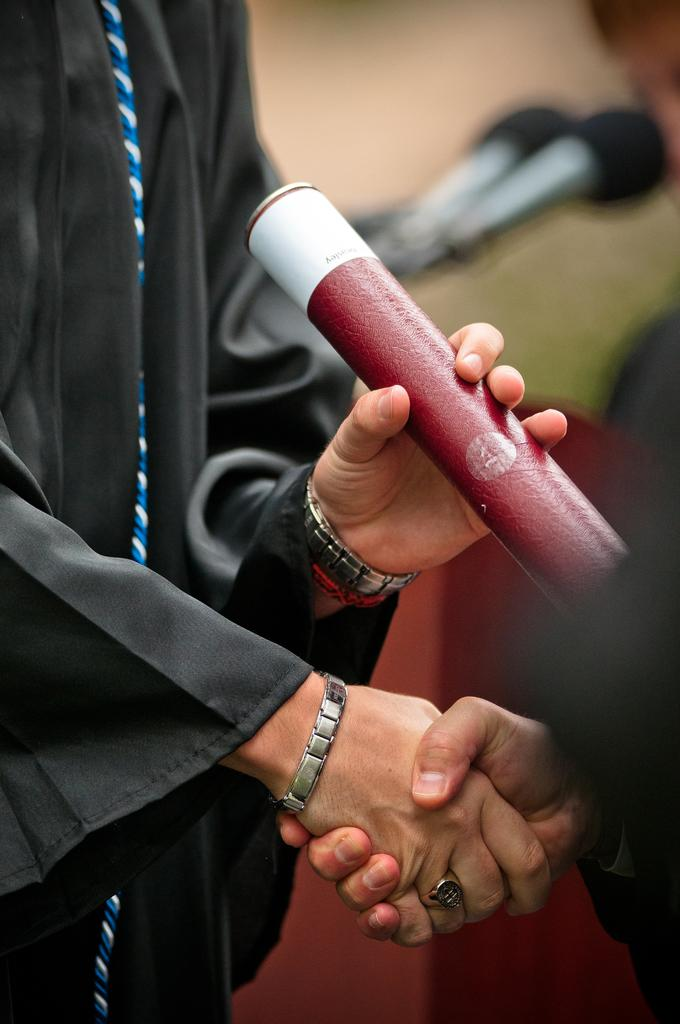What body parts are visible in the image? There are person's hands in the image. What objects are associated with the hands in the image? There are microphones in the image. What type of toys can be seen in the hands of the person in the image? There are no toys present in the image; only hands and microphones are visible. 